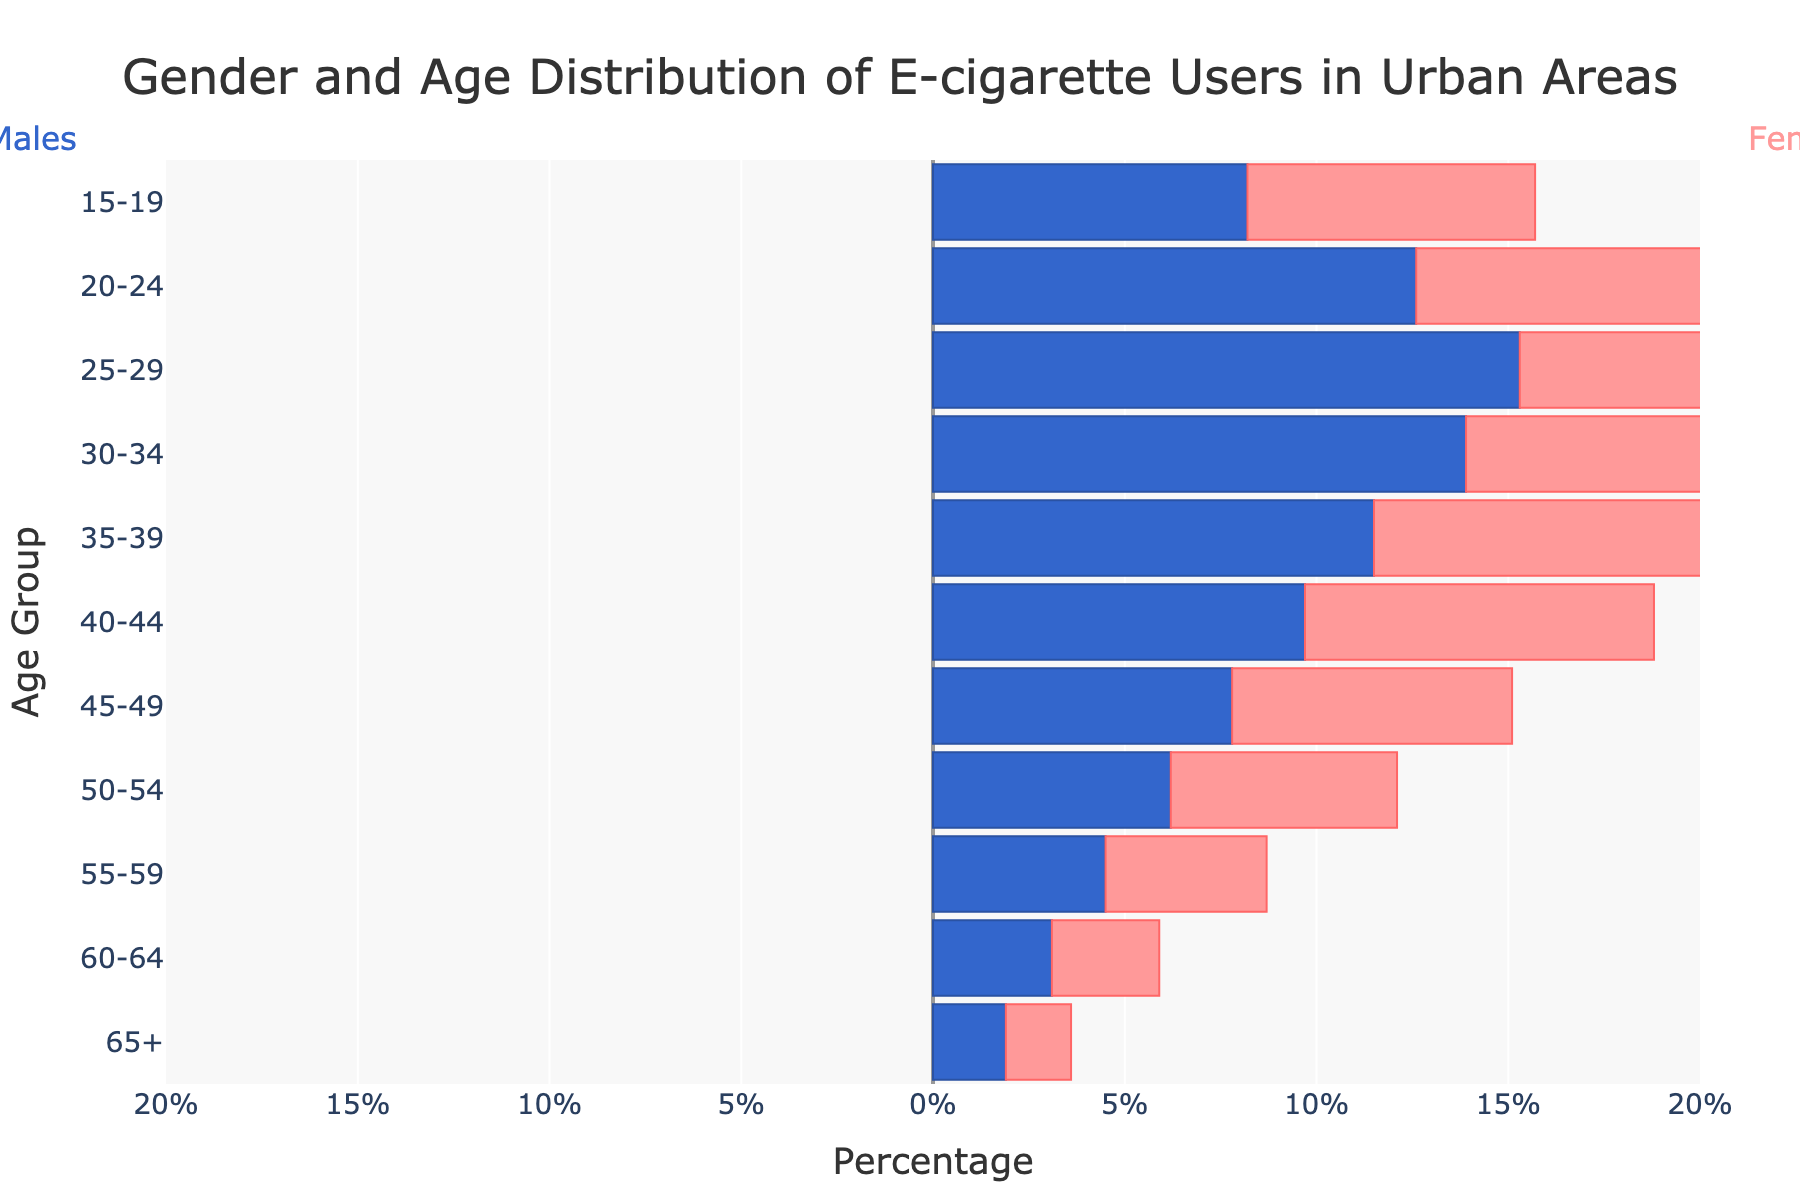What is the title of the figure? The title of the figure is displayed at the top center. It reads "Gender and Age Distribution of E-cigarette Users in Urban Areas".
Answer: Gender and Age Distribution of E-cigarette Users in Urban Areas Which age group has the highest percentage of male e-cigarette users? By looking at the length of the bars representing males, the age group 25-29 has the longest negative bar with a value of -15.3%. This indicates it has the highest percentage of male e-cigarette users.
Answer: 25-29 What are the percentages of male and female e-cigarette users in the 20-24 age group? For the 20-24 age group, the male percentage is represented by a negative bar of -12.6% and the female percentage by a positive bar of 11.8%.
Answer: -12.6% and 11.8% How does the percentage of e-cigarette usage among females compare between the 30-34 and 55-59 age groups? By comparing the lengths of the bars representing females, the 30-34 age group has a bar of 13.2%, whereas the 55-59 age group has a bar of 4.2%. This shows that the 30-34 age group has a significantly higher percentage.
Answer: The 30-34 age group is higher Which gender has a higher percentage of e-cigarette users in the 50-54 age group? By comparing the heights of the bars for the 50-54 age group, males have a bar at -6.2%, while females have a bar at 5.9%. The negative sign indicates the male percentages, and they have a higher absolute value.
Answer: Males What is the total combined percentage of e-cigarette users for males and females in the 15-19 age group? Sum the absolute values of the percentages for males and females in the 15-19 age group: -8.2% for males and 7.5% for females. Thus, 8.2 + 7.5 = 15.7%.
Answer: 15.7% Between males and females, who shows a more consistent percentage drop across successive age groups? By observing the male and female bars across successive age groups, the male bars show a more gradual and consistent decrease in percentage from the highest to the lowest, compared to females.
Answer: Males What percentage difference is observed between male and female e-cigarette users in the 35-39 age group? The percentage for males is -11.5%, and for females, it is 10.8%. The difference is calculated as 11.5 - 10.8 = 0.7%.
Answer: 0.7% Which gender has the smallest representation in the e-cigarette user population for the 65+ age group? The 65+ age group has -1.9% for males and 1.7% for females. The smallest (more negative) percentage is -1.9% for males.
Answer: Males What is the range of the x-axis in the figure? The x-axis range is marked from -20% to 20%, ensuring that the values are displayed in the visual for both genders.
Answer: -20 to 20 